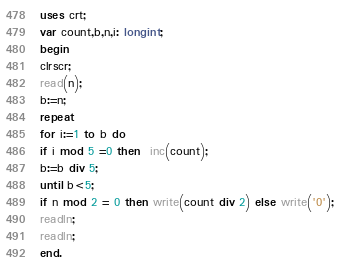Convert code to text. <code><loc_0><loc_0><loc_500><loc_500><_Pascal_>uses crt;
var count,b,n,i: longint;
begin
clrscr;
read(n);
b:=n;
repeat
for i:=1 to b do
if i mod 5 =0 then  inc(count);
b:=b div 5;
until b<5;
if n mod 2 = 0 then write(count div 2) else write('0');
readln;
readln;
end.
</code> 